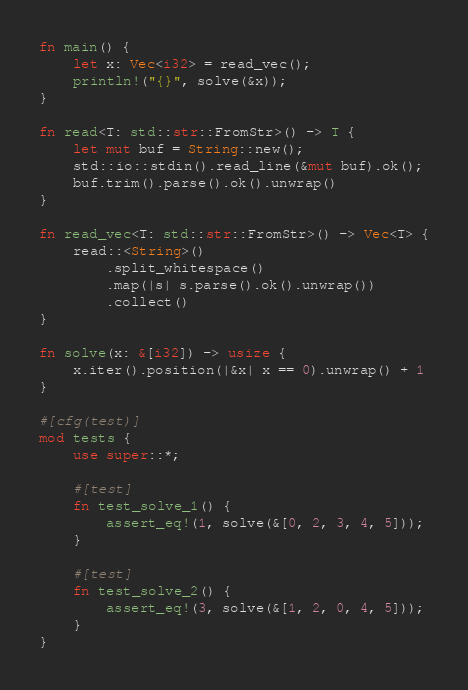Convert code to text. <code><loc_0><loc_0><loc_500><loc_500><_Rust_>fn main() {
    let x: Vec<i32> = read_vec();
    println!("{}", solve(&x));
}

fn read<T: std::str::FromStr>() -> T {
    let mut buf = String::new();
    std::io::stdin().read_line(&mut buf).ok();
    buf.trim().parse().ok().unwrap()
}

fn read_vec<T: std::str::FromStr>() -> Vec<T> {
    read::<String>()
        .split_whitespace()
        .map(|s| s.parse().ok().unwrap())
        .collect()
}

fn solve(x: &[i32]) -> usize {
    x.iter().position(|&x| x == 0).unwrap() + 1
}

#[cfg(test)]
mod tests {
    use super::*;

    #[test]
    fn test_solve_1() {
        assert_eq!(1, solve(&[0, 2, 3, 4, 5]));
    }

    #[test]
    fn test_solve_2() {
        assert_eq!(3, solve(&[1, 2, 0, 4, 5]));
    }
}
</code> 